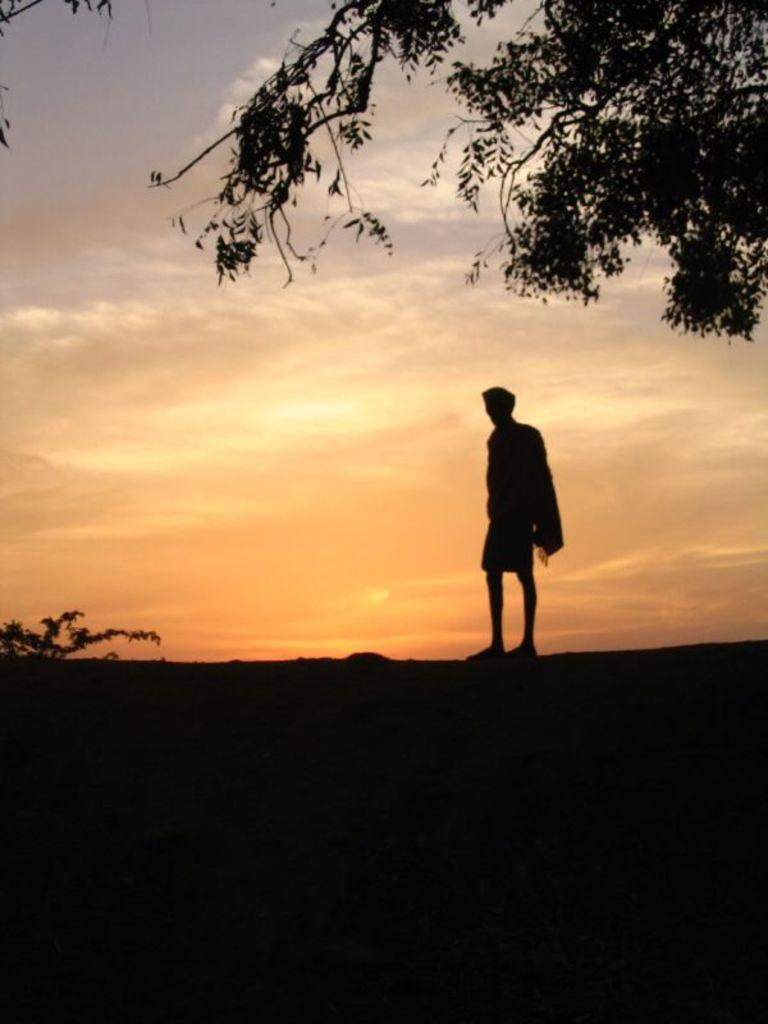What is the main subject in the image? There is a man standing in the image. What other objects or elements can be seen in the image? There is a tree and the sky is visible in the image. How many snails can be seen climbing up the tree in the image? There are no snails visible in the image; it only features a man, a tree, and the sky. 